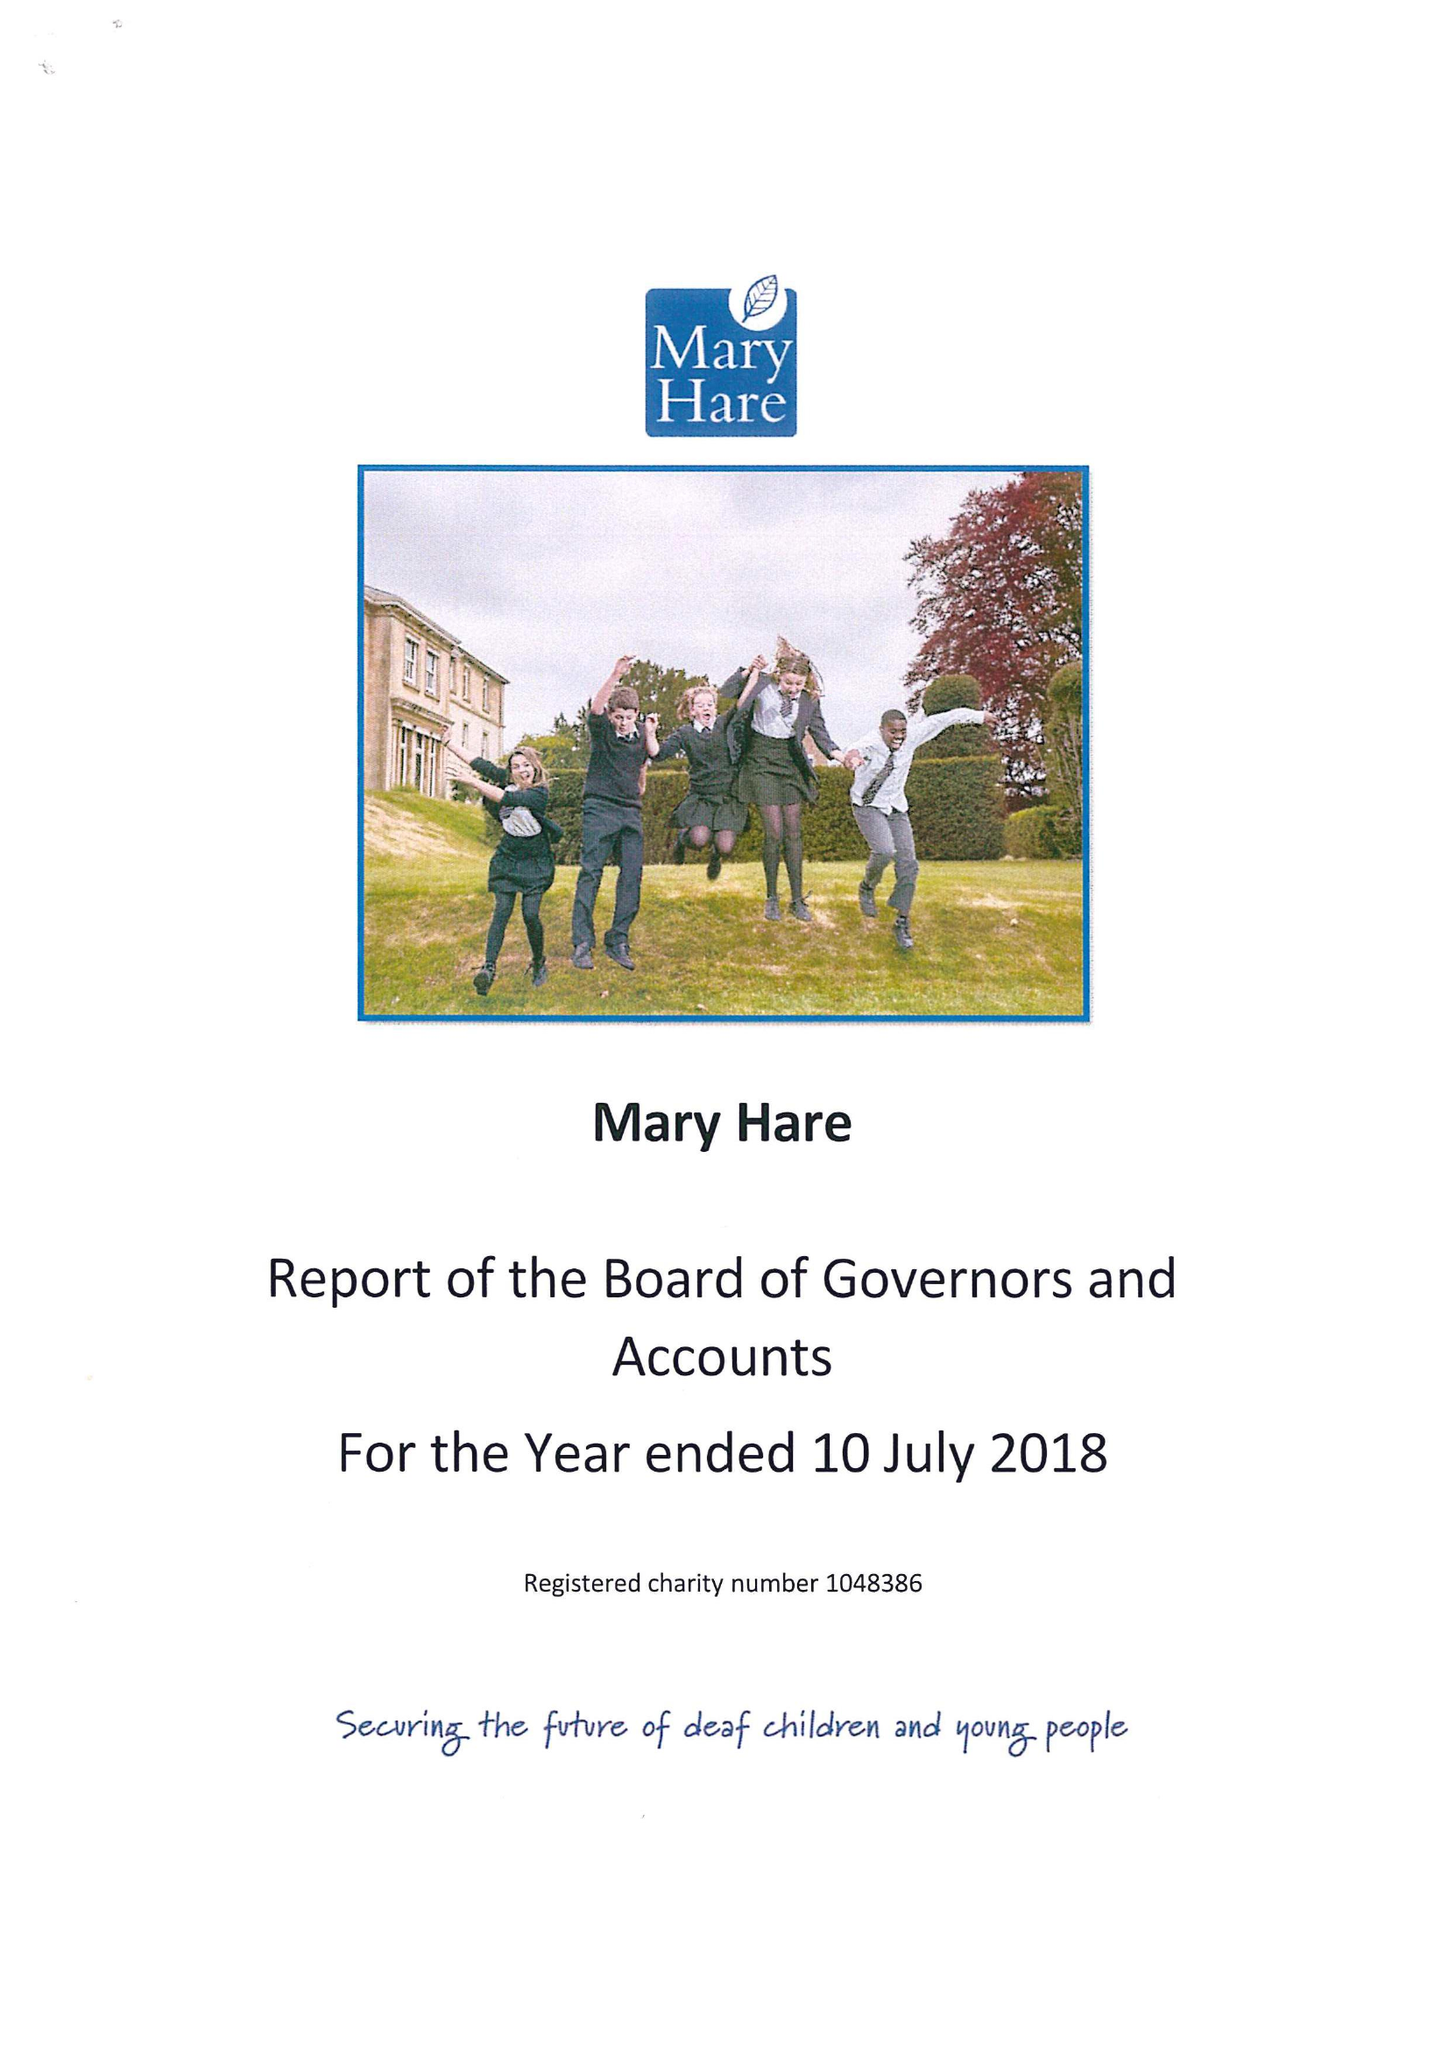What is the value for the spending_annually_in_british_pounds?
Answer the question using a single word or phrase. 13478000.00 